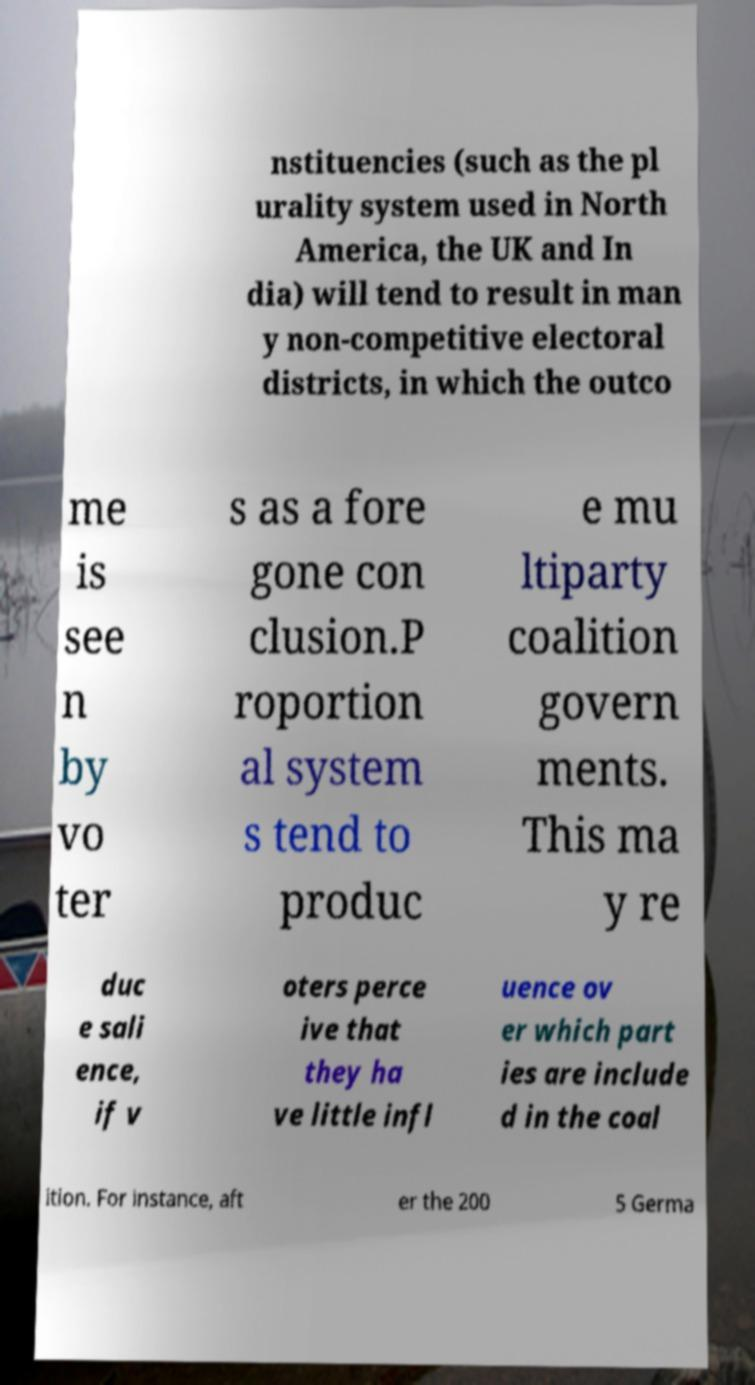Could you extract and type out the text from this image? nstituencies (such as the pl urality system used in North America, the UK and In dia) will tend to result in man y non-competitive electoral districts, in which the outco me is see n by vo ter s as a fore gone con clusion.P roportion al system s tend to produc e mu ltiparty coalition govern ments. This ma y re duc e sali ence, if v oters perce ive that they ha ve little infl uence ov er which part ies are include d in the coal ition. For instance, aft er the 200 5 Germa 